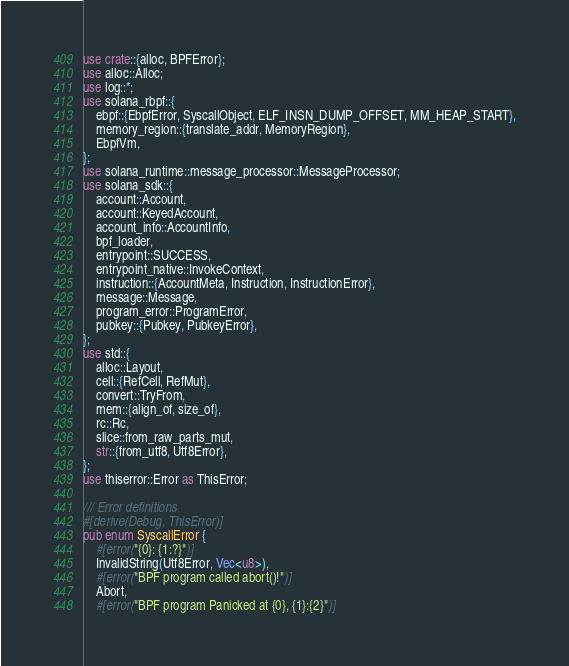<code> <loc_0><loc_0><loc_500><loc_500><_Rust_>use crate::{alloc, BPFError};
use alloc::Alloc;
use log::*;
use solana_rbpf::{
    ebpf::{EbpfError, SyscallObject, ELF_INSN_DUMP_OFFSET, MM_HEAP_START},
    memory_region::{translate_addr, MemoryRegion},
    EbpfVm,
};
use solana_runtime::message_processor::MessageProcessor;
use solana_sdk::{
    account::Account,
    account::KeyedAccount,
    account_info::AccountInfo,
    bpf_loader,
    entrypoint::SUCCESS,
    entrypoint_native::InvokeContext,
    instruction::{AccountMeta, Instruction, InstructionError},
    message::Message,
    program_error::ProgramError,
    pubkey::{Pubkey, PubkeyError},
};
use std::{
    alloc::Layout,
    cell::{RefCell, RefMut},
    convert::TryFrom,
    mem::{align_of, size_of},
    rc::Rc,
    slice::from_raw_parts_mut,
    str::{from_utf8, Utf8Error},
};
use thiserror::Error as ThisError;

/// Error definitions
#[derive(Debug, ThisError)]
pub enum SyscallError {
    #[error("{0}: {1:?}")]
    InvalidString(Utf8Error, Vec<u8>),
    #[error("BPF program called abort()!")]
    Abort,
    #[error("BPF program Panicked at {0}, {1}:{2}")]</code> 